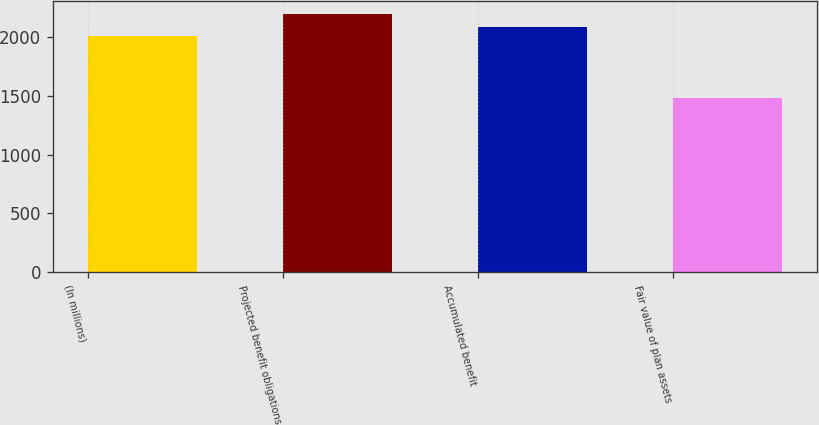Convert chart. <chart><loc_0><loc_0><loc_500><loc_500><bar_chart><fcel>(In millions)<fcel>Projected benefit obligations<fcel>Accumulated benefit<fcel>Fair value of plan assets<nl><fcel>2012<fcel>2192<fcel>2083.4<fcel>1478<nl></chart> 